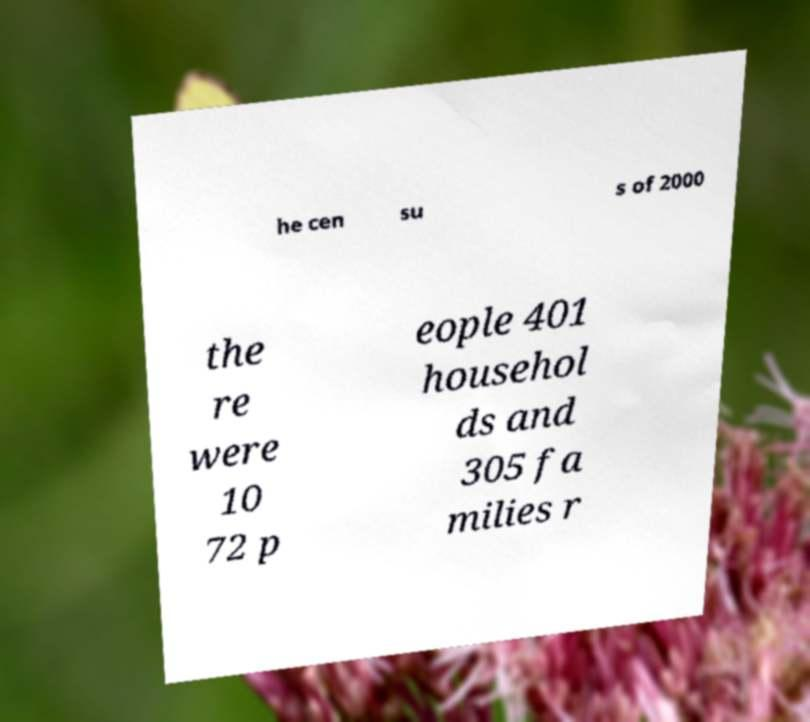Please identify and transcribe the text found in this image. he cen su s of 2000 the re were 10 72 p eople 401 househol ds and 305 fa milies r 